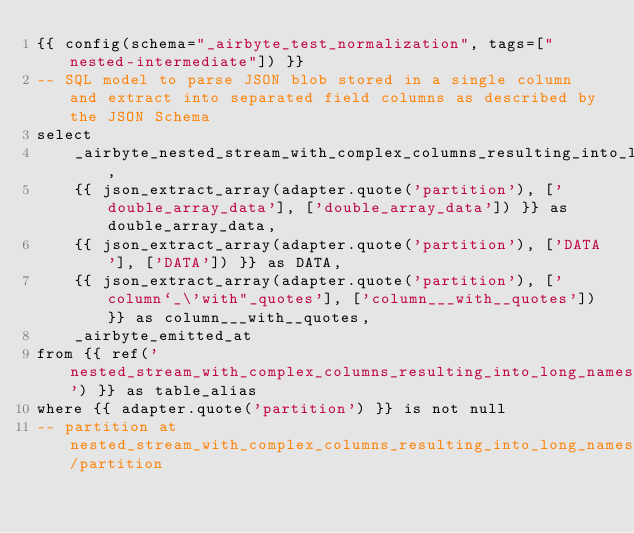Convert code to text. <code><loc_0><loc_0><loc_500><loc_500><_SQL_>{{ config(schema="_airbyte_test_normalization", tags=["nested-intermediate"]) }}
-- SQL model to parse JSON blob stored in a single column and extract into separated field columns as described by the JSON Schema
select
    _airbyte_nested_stream_with_complex_columns_resulting_into_long_names_hashid,
    {{ json_extract_array(adapter.quote('partition'), ['double_array_data'], ['double_array_data']) }} as double_array_data,
    {{ json_extract_array(adapter.quote('partition'), ['DATA'], ['DATA']) }} as DATA,
    {{ json_extract_array(adapter.quote('partition'), ['column`_\'with"_quotes'], ['column___with__quotes']) }} as column___with__quotes,
    _airbyte_emitted_at
from {{ ref('nested_stream_with_complex_columns_resulting_into_long_names') }} as table_alias
where {{ adapter.quote('partition') }} is not null
-- partition at nested_stream_with_complex_columns_resulting_into_long_names/partition

</code> 